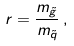<formula> <loc_0><loc_0><loc_500><loc_500>r = \frac { m _ { \tilde { g } } } { m _ { \tilde { q } } } \, ,</formula> 